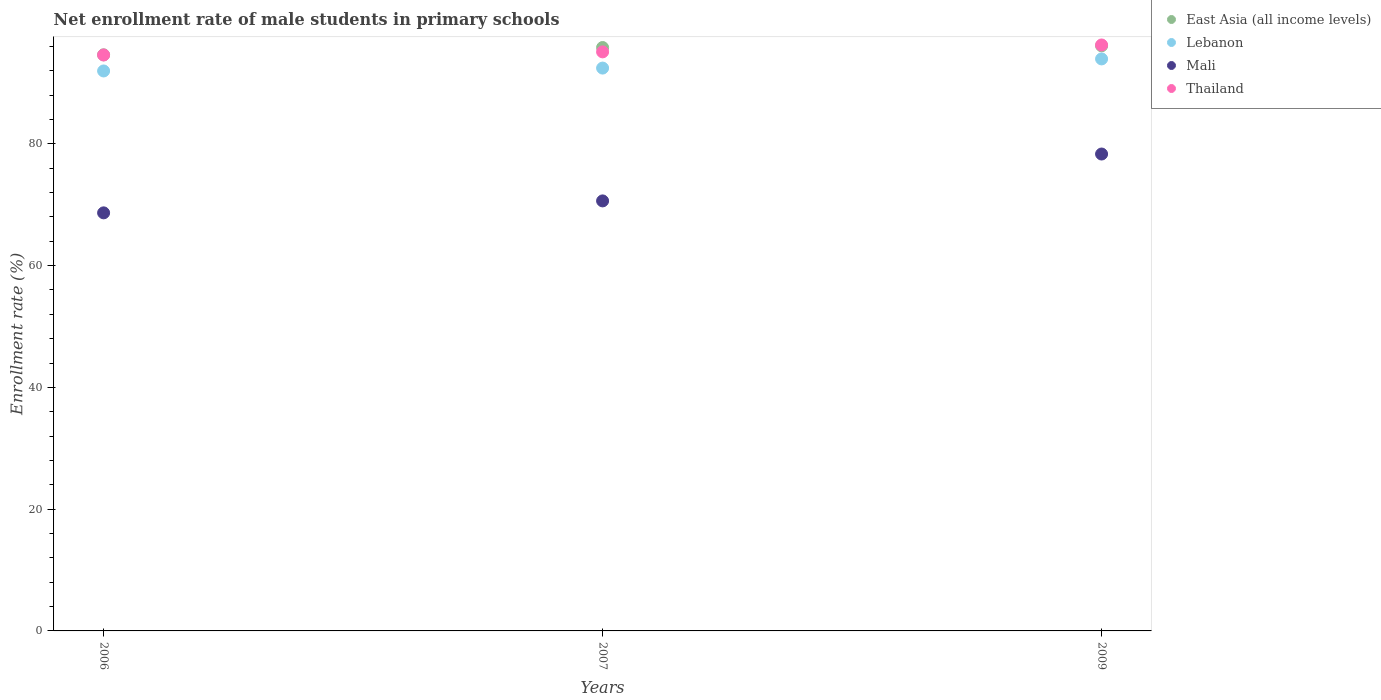What is the net enrollment rate of male students in primary schools in East Asia (all income levels) in 2006?
Make the answer very short. 94.63. Across all years, what is the maximum net enrollment rate of male students in primary schools in Lebanon?
Provide a succinct answer. 93.96. Across all years, what is the minimum net enrollment rate of male students in primary schools in Lebanon?
Your answer should be compact. 91.98. In which year was the net enrollment rate of male students in primary schools in Mali minimum?
Offer a terse response. 2006. What is the total net enrollment rate of male students in primary schools in Mali in the graph?
Make the answer very short. 217.64. What is the difference between the net enrollment rate of male students in primary schools in Lebanon in 2007 and that in 2009?
Your response must be concise. -1.51. What is the difference between the net enrollment rate of male students in primary schools in East Asia (all income levels) in 2009 and the net enrollment rate of male students in primary schools in Lebanon in 2007?
Ensure brevity in your answer.  3.66. What is the average net enrollment rate of male students in primary schools in East Asia (all income levels) per year?
Give a very brief answer. 95.52. In the year 2009, what is the difference between the net enrollment rate of male students in primary schools in East Asia (all income levels) and net enrollment rate of male students in primary schools in Lebanon?
Offer a very short reply. 2.15. In how many years, is the net enrollment rate of male students in primary schools in Mali greater than 92 %?
Keep it short and to the point. 0. What is the ratio of the net enrollment rate of male students in primary schools in Thailand in 2007 to that in 2009?
Give a very brief answer. 0.99. Is the net enrollment rate of male students in primary schools in East Asia (all income levels) in 2007 less than that in 2009?
Make the answer very short. Yes. What is the difference between the highest and the second highest net enrollment rate of male students in primary schools in Mali?
Give a very brief answer. 7.7. What is the difference between the highest and the lowest net enrollment rate of male students in primary schools in Thailand?
Your answer should be compact. 1.65. In how many years, is the net enrollment rate of male students in primary schools in Lebanon greater than the average net enrollment rate of male students in primary schools in Lebanon taken over all years?
Provide a succinct answer. 1. Is the sum of the net enrollment rate of male students in primary schools in Thailand in 2007 and 2009 greater than the maximum net enrollment rate of male students in primary schools in Mali across all years?
Provide a succinct answer. Yes. Is it the case that in every year, the sum of the net enrollment rate of male students in primary schools in Thailand and net enrollment rate of male students in primary schools in Lebanon  is greater than the sum of net enrollment rate of male students in primary schools in East Asia (all income levels) and net enrollment rate of male students in primary schools in Mali?
Make the answer very short. Yes. Is it the case that in every year, the sum of the net enrollment rate of male students in primary schools in East Asia (all income levels) and net enrollment rate of male students in primary schools in Lebanon  is greater than the net enrollment rate of male students in primary schools in Mali?
Offer a terse response. Yes. Does the net enrollment rate of male students in primary schools in Lebanon monotonically increase over the years?
Keep it short and to the point. Yes. Is the net enrollment rate of male students in primary schools in East Asia (all income levels) strictly less than the net enrollment rate of male students in primary schools in Lebanon over the years?
Your response must be concise. No. How many dotlines are there?
Make the answer very short. 4. Does the graph contain any zero values?
Offer a terse response. No. Does the graph contain grids?
Provide a short and direct response. No. Where does the legend appear in the graph?
Your answer should be compact. Top right. What is the title of the graph?
Make the answer very short. Net enrollment rate of male students in primary schools. What is the label or title of the Y-axis?
Provide a succinct answer. Enrollment rate (%). What is the Enrollment rate (%) of East Asia (all income levels) in 2006?
Your response must be concise. 94.63. What is the Enrollment rate (%) in Lebanon in 2006?
Make the answer very short. 91.98. What is the Enrollment rate (%) in Mali in 2006?
Your answer should be compact. 68.67. What is the Enrollment rate (%) of Thailand in 2006?
Ensure brevity in your answer.  94.6. What is the Enrollment rate (%) of East Asia (all income levels) in 2007?
Offer a terse response. 95.83. What is the Enrollment rate (%) in Lebanon in 2007?
Make the answer very short. 92.45. What is the Enrollment rate (%) in Mali in 2007?
Provide a succinct answer. 70.63. What is the Enrollment rate (%) in Thailand in 2007?
Provide a succinct answer. 95.11. What is the Enrollment rate (%) of East Asia (all income levels) in 2009?
Your answer should be very brief. 96.11. What is the Enrollment rate (%) in Lebanon in 2009?
Offer a terse response. 93.96. What is the Enrollment rate (%) of Mali in 2009?
Your response must be concise. 78.33. What is the Enrollment rate (%) of Thailand in 2009?
Ensure brevity in your answer.  96.25. Across all years, what is the maximum Enrollment rate (%) of East Asia (all income levels)?
Give a very brief answer. 96.11. Across all years, what is the maximum Enrollment rate (%) in Lebanon?
Your response must be concise. 93.96. Across all years, what is the maximum Enrollment rate (%) of Mali?
Ensure brevity in your answer.  78.33. Across all years, what is the maximum Enrollment rate (%) in Thailand?
Provide a succinct answer. 96.25. Across all years, what is the minimum Enrollment rate (%) in East Asia (all income levels)?
Ensure brevity in your answer.  94.63. Across all years, what is the minimum Enrollment rate (%) in Lebanon?
Provide a short and direct response. 91.98. Across all years, what is the minimum Enrollment rate (%) in Mali?
Provide a short and direct response. 68.67. Across all years, what is the minimum Enrollment rate (%) of Thailand?
Ensure brevity in your answer.  94.6. What is the total Enrollment rate (%) of East Asia (all income levels) in the graph?
Provide a succinct answer. 286.57. What is the total Enrollment rate (%) in Lebanon in the graph?
Offer a terse response. 278.38. What is the total Enrollment rate (%) of Mali in the graph?
Offer a terse response. 217.64. What is the total Enrollment rate (%) of Thailand in the graph?
Your response must be concise. 285.96. What is the difference between the Enrollment rate (%) in East Asia (all income levels) in 2006 and that in 2007?
Your answer should be very brief. -1.2. What is the difference between the Enrollment rate (%) in Lebanon in 2006 and that in 2007?
Your answer should be compact. -0.47. What is the difference between the Enrollment rate (%) of Mali in 2006 and that in 2007?
Make the answer very short. -1.96. What is the difference between the Enrollment rate (%) of Thailand in 2006 and that in 2007?
Offer a terse response. -0.51. What is the difference between the Enrollment rate (%) of East Asia (all income levels) in 2006 and that in 2009?
Offer a very short reply. -1.48. What is the difference between the Enrollment rate (%) in Lebanon in 2006 and that in 2009?
Give a very brief answer. -1.98. What is the difference between the Enrollment rate (%) in Mali in 2006 and that in 2009?
Keep it short and to the point. -9.66. What is the difference between the Enrollment rate (%) of Thailand in 2006 and that in 2009?
Give a very brief answer. -1.65. What is the difference between the Enrollment rate (%) in East Asia (all income levels) in 2007 and that in 2009?
Offer a terse response. -0.28. What is the difference between the Enrollment rate (%) in Lebanon in 2007 and that in 2009?
Make the answer very short. -1.51. What is the difference between the Enrollment rate (%) in Mali in 2007 and that in 2009?
Ensure brevity in your answer.  -7.7. What is the difference between the Enrollment rate (%) of Thailand in 2007 and that in 2009?
Provide a succinct answer. -1.13. What is the difference between the Enrollment rate (%) of East Asia (all income levels) in 2006 and the Enrollment rate (%) of Lebanon in 2007?
Give a very brief answer. 2.18. What is the difference between the Enrollment rate (%) of East Asia (all income levels) in 2006 and the Enrollment rate (%) of Mali in 2007?
Make the answer very short. 24. What is the difference between the Enrollment rate (%) of East Asia (all income levels) in 2006 and the Enrollment rate (%) of Thailand in 2007?
Ensure brevity in your answer.  -0.48. What is the difference between the Enrollment rate (%) of Lebanon in 2006 and the Enrollment rate (%) of Mali in 2007?
Ensure brevity in your answer.  21.34. What is the difference between the Enrollment rate (%) in Lebanon in 2006 and the Enrollment rate (%) in Thailand in 2007?
Provide a short and direct response. -3.14. What is the difference between the Enrollment rate (%) of Mali in 2006 and the Enrollment rate (%) of Thailand in 2007?
Your answer should be very brief. -26.44. What is the difference between the Enrollment rate (%) of East Asia (all income levels) in 2006 and the Enrollment rate (%) of Lebanon in 2009?
Your answer should be compact. 0.67. What is the difference between the Enrollment rate (%) of East Asia (all income levels) in 2006 and the Enrollment rate (%) of Mali in 2009?
Give a very brief answer. 16.3. What is the difference between the Enrollment rate (%) in East Asia (all income levels) in 2006 and the Enrollment rate (%) in Thailand in 2009?
Offer a terse response. -1.62. What is the difference between the Enrollment rate (%) of Lebanon in 2006 and the Enrollment rate (%) of Mali in 2009?
Offer a terse response. 13.64. What is the difference between the Enrollment rate (%) in Lebanon in 2006 and the Enrollment rate (%) in Thailand in 2009?
Keep it short and to the point. -4.27. What is the difference between the Enrollment rate (%) of Mali in 2006 and the Enrollment rate (%) of Thailand in 2009?
Your response must be concise. -27.58. What is the difference between the Enrollment rate (%) in East Asia (all income levels) in 2007 and the Enrollment rate (%) in Lebanon in 2009?
Your response must be concise. 1.87. What is the difference between the Enrollment rate (%) of East Asia (all income levels) in 2007 and the Enrollment rate (%) of Mali in 2009?
Keep it short and to the point. 17.5. What is the difference between the Enrollment rate (%) in East Asia (all income levels) in 2007 and the Enrollment rate (%) in Thailand in 2009?
Your answer should be compact. -0.42. What is the difference between the Enrollment rate (%) of Lebanon in 2007 and the Enrollment rate (%) of Mali in 2009?
Your response must be concise. 14.12. What is the difference between the Enrollment rate (%) of Lebanon in 2007 and the Enrollment rate (%) of Thailand in 2009?
Ensure brevity in your answer.  -3.8. What is the difference between the Enrollment rate (%) of Mali in 2007 and the Enrollment rate (%) of Thailand in 2009?
Give a very brief answer. -25.61. What is the average Enrollment rate (%) of East Asia (all income levels) per year?
Offer a very short reply. 95.52. What is the average Enrollment rate (%) of Lebanon per year?
Offer a terse response. 92.79. What is the average Enrollment rate (%) of Mali per year?
Ensure brevity in your answer.  72.55. What is the average Enrollment rate (%) of Thailand per year?
Keep it short and to the point. 95.32. In the year 2006, what is the difference between the Enrollment rate (%) of East Asia (all income levels) and Enrollment rate (%) of Lebanon?
Your answer should be very brief. 2.65. In the year 2006, what is the difference between the Enrollment rate (%) of East Asia (all income levels) and Enrollment rate (%) of Mali?
Offer a very short reply. 25.96. In the year 2006, what is the difference between the Enrollment rate (%) in East Asia (all income levels) and Enrollment rate (%) in Thailand?
Make the answer very short. 0.03. In the year 2006, what is the difference between the Enrollment rate (%) of Lebanon and Enrollment rate (%) of Mali?
Give a very brief answer. 23.31. In the year 2006, what is the difference between the Enrollment rate (%) of Lebanon and Enrollment rate (%) of Thailand?
Your answer should be very brief. -2.62. In the year 2006, what is the difference between the Enrollment rate (%) in Mali and Enrollment rate (%) in Thailand?
Your answer should be very brief. -25.93. In the year 2007, what is the difference between the Enrollment rate (%) in East Asia (all income levels) and Enrollment rate (%) in Lebanon?
Offer a terse response. 3.38. In the year 2007, what is the difference between the Enrollment rate (%) in East Asia (all income levels) and Enrollment rate (%) in Mali?
Your answer should be very brief. 25.2. In the year 2007, what is the difference between the Enrollment rate (%) of East Asia (all income levels) and Enrollment rate (%) of Thailand?
Offer a very short reply. 0.72. In the year 2007, what is the difference between the Enrollment rate (%) in Lebanon and Enrollment rate (%) in Mali?
Your answer should be compact. 21.82. In the year 2007, what is the difference between the Enrollment rate (%) of Lebanon and Enrollment rate (%) of Thailand?
Make the answer very short. -2.66. In the year 2007, what is the difference between the Enrollment rate (%) in Mali and Enrollment rate (%) in Thailand?
Offer a terse response. -24.48. In the year 2009, what is the difference between the Enrollment rate (%) of East Asia (all income levels) and Enrollment rate (%) of Lebanon?
Your response must be concise. 2.15. In the year 2009, what is the difference between the Enrollment rate (%) in East Asia (all income levels) and Enrollment rate (%) in Mali?
Provide a succinct answer. 17.77. In the year 2009, what is the difference between the Enrollment rate (%) in East Asia (all income levels) and Enrollment rate (%) in Thailand?
Make the answer very short. -0.14. In the year 2009, what is the difference between the Enrollment rate (%) in Lebanon and Enrollment rate (%) in Mali?
Your answer should be compact. 15.62. In the year 2009, what is the difference between the Enrollment rate (%) of Lebanon and Enrollment rate (%) of Thailand?
Keep it short and to the point. -2.29. In the year 2009, what is the difference between the Enrollment rate (%) in Mali and Enrollment rate (%) in Thailand?
Give a very brief answer. -17.91. What is the ratio of the Enrollment rate (%) in East Asia (all income levels) in 2006 to that in 2007?
Give a very brief answer. 0.99. What is the ratio of the Enrollment rate (%) in Mali in 2006 to that in 2007?
Your response must be concise. 0.97. What is the ratio of the Enrollment rate (%) in Thailand in 2006 to that in 2007?
Give a very brief answer. 0.99. What is the ratio of the Enrollment rate (%) in East Asia (all income levels) in 2006 to that in 2009?
Provide a succinct answer. 0.98. What is the ratio of the Enrollment rate (%) in Lebanon in 2006 to that in 2009?
Provide a succinct answer. 0.98. What is the ratio of the Enrollment rate (%) in Mali in 2006 to that in 2009?
Make the answer very short. 0.88. What is the ratio of the Enrollment rate (%) of Thailand in 2006 to that in 2009?
Your answer should be compact. 0.98. What is the ratio of the Enrollment rate (%) in Lebanon in 2007 to that in 2009?
Give a very brief answer. 0.98. What is the ratio of the Enrollment rate (%) of Mali in 2007 to that in 2009?
Your answer should be very brief. 0.9. What is the ratio of the Enrollment rate (%) in Thailand in 2007 to that in 2009?
Your answer should be very brief. 0.99. What is the difference between the highest and the second highest Enrollment rate (%) of East Asia (all income levels)?
Your answer should be compact. 0.28. What is the difference between the highest and the second highest Enrollment rate (%) in Lebanon?
Provide a succinct answer. 1.51. What is the difference between the highest and the second highest Enrollment rate (%) of Mali?
Make the answer very short. 7.7. What is the difference between the highest and the second highest Enrollment rate (%) in Thailand?
Your answer should be compact. 1.13. What is the difference between the highest and the lowest Enrollment rate (%) in East Asia (all income levels)?
Your answer should be compact. 1.48. What is the difference between the highest and the lowest Enrollment rate (%) in Lebanon?
Your answer should be very brief. 1.98. What is the difference between the highest and the lowest Enrollment rate (%) of Mali?
Keep it short and to the point. 9.66. What is the difference between the highest and the lowest Enrollment rate (%) in Thailand?
Your response must be concise. 1.65. 